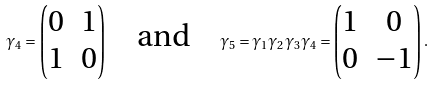Convert formula to latex. <formula><loc_0><loc_0><loc_500><loc_500>\gamma _ { 4 } = \begin{pmatrix} 0 & \mathbb { m } { 1 } \\ \mathbb { m } { 1 } & 0 \\ \end{pmatrix} \quad \text {and} \quad \gamma _ { 5 } = \gamma _ { 1 } \gamma _ { 2 } \gamma _ { 3 } \gamma _ { 4 } = \begin{pmatrix} \mathbb { m } { 1 } & 0 \\ 0 & - \mathbb { m } { 1 } \\ \end{pmatrix} .</formula> 